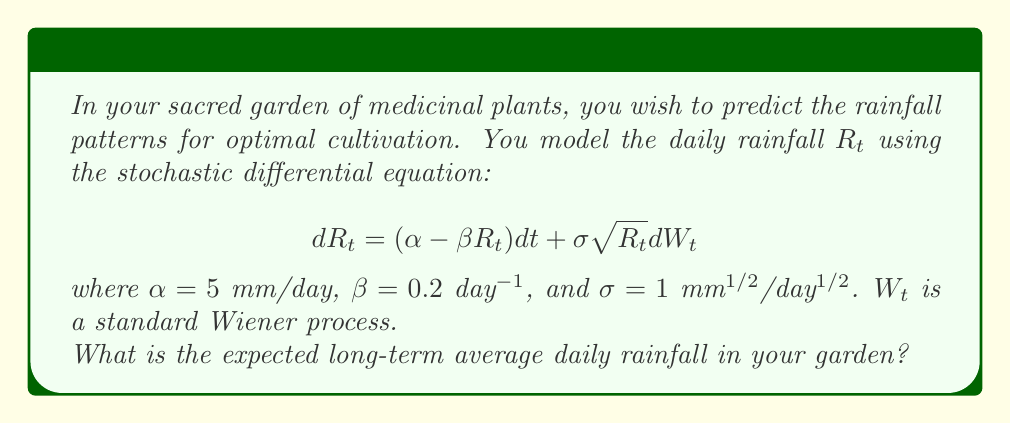Help me with this question. To find the long-term average daily rainfall, we need to determine the stationary distribution of the stochastic process. For this type of stochastic differential equation (known as the Cox-Ingersoll-Ross model), the stationary distribution is known to be a Gamma distribution.

Step 1: Identify the parameters of the Gamma distribution.
The Gamma distribution for this process has shape parameter $k = \frac{2\alpha}{\sigma^2}$ and scale parameter $\theta = \frac{\sigma^2}{2\beta}$.

Step 2: Calculate the shape parameter $k$.
$k = \frac{2\alpha}{\sigma^2} = \frac{2 \cdot 5}{1^2} = 10$

Step 3: Calculate the scale parameter $\theta$.
$\theta = \frac{\sigma^2}{2\beta} = \frac{1^2}{2 \cdot 0.2} = 2.5$

Step 4: Determine the expected value of the Gamma distribution.
For a Gamma distribution, the expected value is given by $E[X] = k\theta$.

$E[R_t] = k\theta = 10 \cdot 2.5 = 25$

Therefore, the expected long-term average daily rainfall is 25 mm/day.
Answer: 25 mm/day 